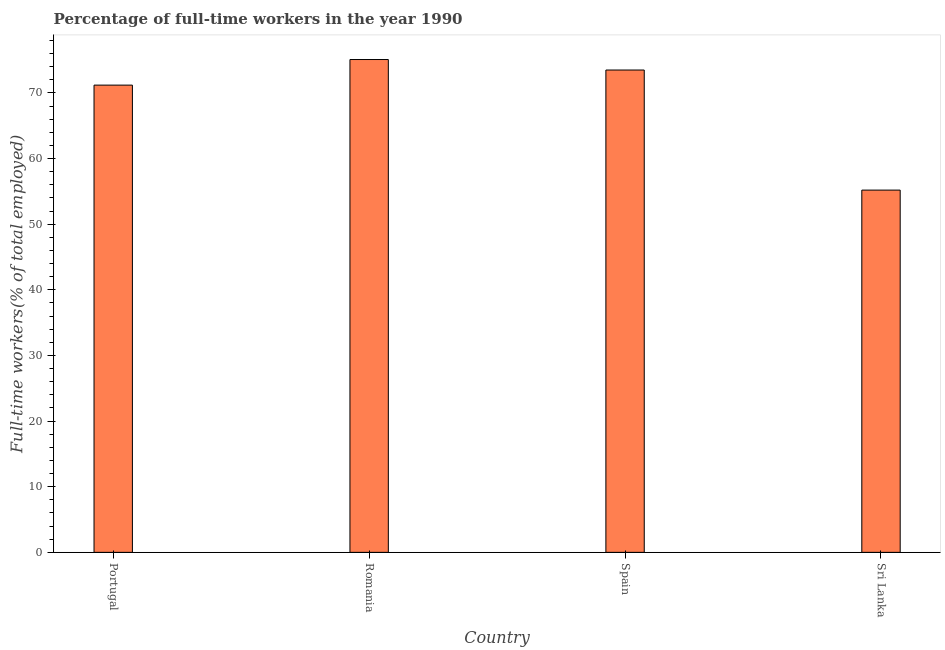Does the graph contain any zero values?
Your answer should be very brief. No. What is the title of the graph?
Give a very brief answer. Percentage of full-time workers in the year 1990. What is the label or title of the X-axis?
Keep it short and to the point. Country. What is the label or title of the Y-axis?
Keep it short and to the point. Full-time workers(% of total employed). What is the percentage of full-time workers in Portugal?
Your response must be concise. 71.2. Across all countries, what is the maximum percentage of full-time workers?
Your response must be concise. 75.1. Across all countries, what is the minimum percentage of full-time workers?
Your answer should be compact. 55.2. In which country was the percentage of full-time workers maximum?
Your answer should be very brief. Romania. In which country was the percentage of full-time workers minimum?
Keep it short and to the point. Sri Lanka. What is the sum of the percentage of full-time workers?
Offer a very short reply. 275. What is the difference between the percentage of full-time workers in Romania and Sri Lanka?
Provide a short and direct response. 19.9. What is the average percentage of full-time workers per country?
Provide a short and direct response. 68.75. What is the median percentage of full-time workers?
Ensure brevity in your answer.  72.35. What is the ratio of the percentage of full-time workers in Portugal to that in Romania?
Offer a terse response. 0.95. Is the percentage of full-time workers in Romania less than that in Sri Lanka?
Ensure brevity in your answer.  No. What is the difference between the highest and the second highest percentage of full-time workers?
Give a very brief answer. 1.6. Is the sum of the percentage of full-time workers in Spain and Sri Lanka greater than the maximum percentage of full-time workers across all countries?
Give a very brief answer. Yes. Are all the bars in the graph horizontal?
Your answer should be very brief. No. How many countries are there in the graph?
Provide a short and direct response. 4. What is the Full-time workers(% of total employed) in Portugal?
Your answer should be compact. 71.2. What is the Full-time workers(% of total employed) of Romania?
Keep it short and to the point. 75.1. What is the Full-time workers(% of total employed) in Spain?
Your answer should be compact. 73.5. What is the Full-time workers(% of total employed) of Sri Lanka?
Offer a very short reply. 55.2. What is the difference between the Full-time workers(% of total employed) in Romania and Sri Lanka?
Ensure brevity in your answer.  19.9. What is the ratio of the Full-time workers(% of total employed) in Portugal to that in Romania?
Your answer should be compact. 0.95. What is the ratio of the Full-time workers(% of total employed) in Portugal to that in Sri Lanka?
Ensure brevity in your answer.  1.29. What is the ratio of the Full-time workers(% of total employed) in Romania to that in Spain?
Ensure brevity in your answer.  1.02. What is the ratio of the Full-time workers(% of total employed) in Romania to that in Sri Lanka?
Provide a short and direct response. 1.36. What is the ratio of the Full-time workers(% of total employed) in Spain to that in Sri Lanka?
Ensure brevity in your answer.  1.33. 